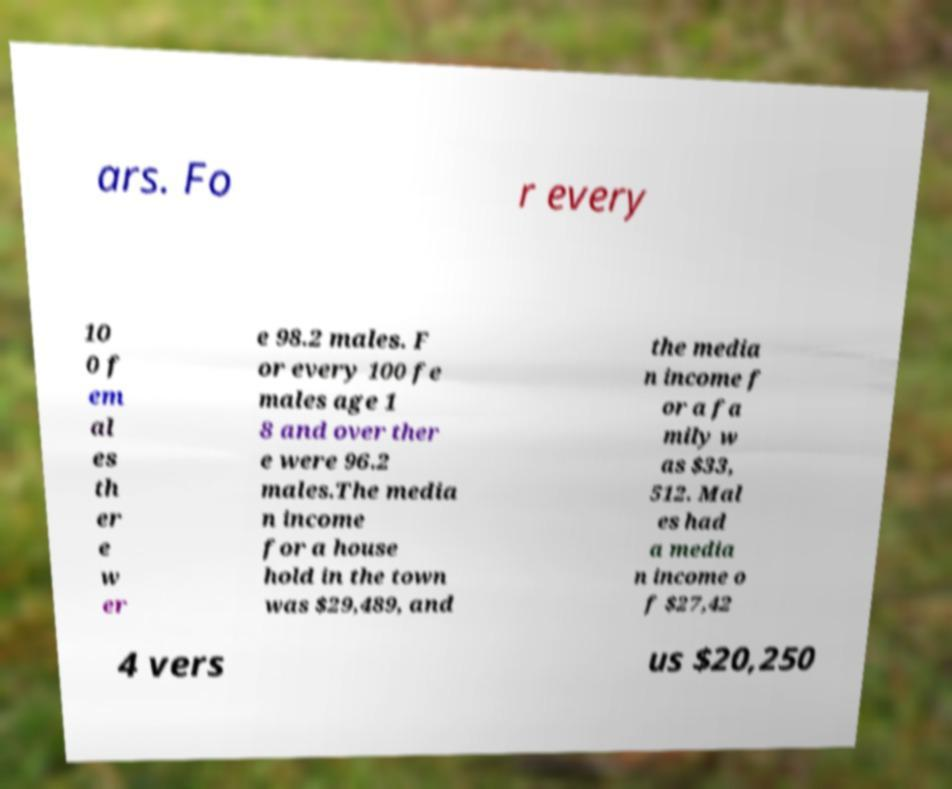For documentation purposes, I need the text within this image transcribed. Could you provide that? ars. Fo r every 10 0 f em al es th er e w er e 98.2 males. F or every 100 fe males age 1 8 and over ther e were 96.2 males.The media n income for a house hold in the town was $29,489, and the media n income f or a fa mily w as $33, 512. Mal es had a media n income o f $27,42 4 vers us $20,250 